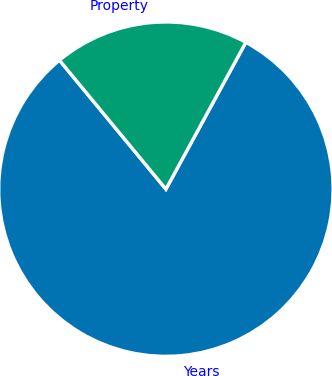Convert chart to OTSL. <chart><loc_0><loc_0><loc_500><loc_500><pie_chart><fcel>Years<fcel>Property<nl><fcel>81.08%<fcel>18.92%<nl></chart> 